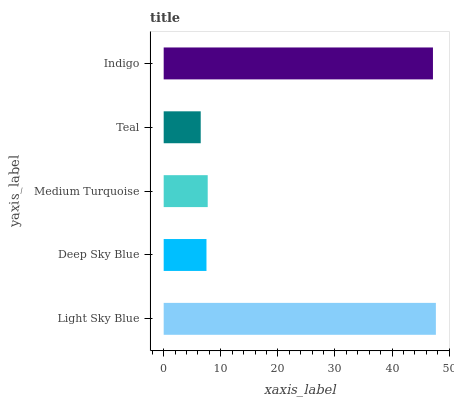Is Teal the minimum?
Answer yes or no. Yes. Is Light Sky Blue the maximum?
Answer yes or no. Yes. Is Deep Sky Blue the minimum?
Answer yes or no. No. Is Deep Sky Blue the maximum?
Answer yes or no. No. Is Light Sky Blue greater than Deep Sky Blue?
Answer yes or no. Yes. Is Deep Sky Blue less than Light Sky Blue?
Answer yes or no. Yes. Is Deep Sky Blue greater than Light Sky Blue?
Answer yes or no. No. Is Light Sky Blue less than Deep Sky Blue?
Answer yes or no. No. Is Medium Turquoise the high median?
Answer yes or no. Yes. Is Medium Turquoise the low median?
Answer yes or no. Yes. Is Teal the high median?
Answer yes or no. No. Is Light Sky Blue the low median?
Answer yes or no. No. 